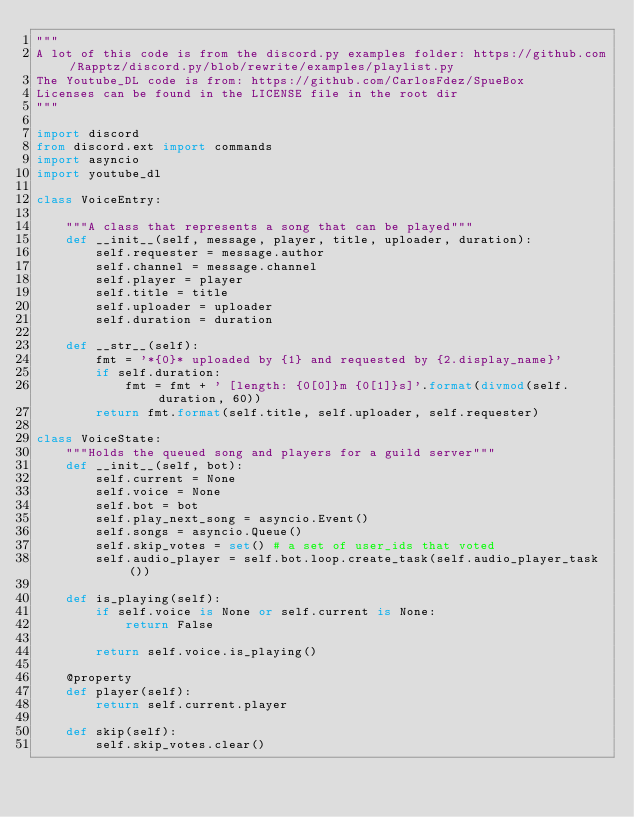Convert code to text. <code><loc_0><loc_0><loc_500><loc_500><_Python_>"""
A lot of this code is from the discord.py examples folder: https://github.com/Rapptz/discord.py/blob/rewrite/examples/playlist.py
The Youtube_DL code is from: https://github.com/CarlosFdez/SpueBox
Licenses can be found in the LICENSE file in the root dir
"""

import discord
from discord.ext import commands
import asyncio
import youtube_dl

class VoiceEntry:

    """A class that represents a song that can be played"""
    def __init__(self, message, player, title, uploader, duration):
        self.requester = message.author
        self.channel = message.channel
        self.player = player
        self.title = title
        self.uploader = uploader
        self.duration = duration

    def __str__(self):
        fmt = '*{0}* uploaded by {1} and requested by {2.display_name}'
        if self.duration:
            fmt = fmt + ' [length: {0[0]}m {0[1]}s]'.format(divmod(self.duration, 60))
        return fmt.format(self.title, self.uploader, self.requester)

class VoiceState:
    """Holds the queued song and players for a guild server"""
    def __init__(self, bot):
        self.current = None
        self.voice = None
        self.bot = bot
        self.play_next_song = asyncio.Event()
        self.songs = asyncio.Queue()
        self.skip_votes = set() # a set of user_ids that voted
        self.audio_player = self.bot.loop.create_task(self.audio_player_task())

    def is_playing(self):
        if self.voice is None or self.current is None:
            return False

        return self.voice.is_playing()

    @property
    def player(self):
        return self.current.player

    def skip(self):
        self.skip_votes.clear()</code> 